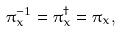Convert formula to latex. <formula><loc_0><loc_0><loc_500><loc_500>\pi _ { x } ^ { - 1 } = \pi _ { x } ^ { \dagger } = \pi _ { x } ,</formula> 